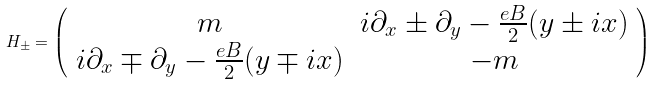<formula> <loc_0><loc_0><loc_500><loc_500>H _ { \pm } = \left ( \begin{array} { c c } { m } & { { i \partial _ { x } \pm \partial _ { y } - \frac { e B } { 2 } ( y \pm i x ) } } \\ { { i \partial _ { x } \mp \partial _ { y } - \frac { e B } { 2 } ( y \mp i x ) } } & { - m } \end{array} \right )</formula> 